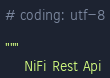Convert code to text. <code><loc_0><loc_0><loc_500><loc_500><_Python_># coding: utf-8

"""
    NiFi Rest Api
</code> 